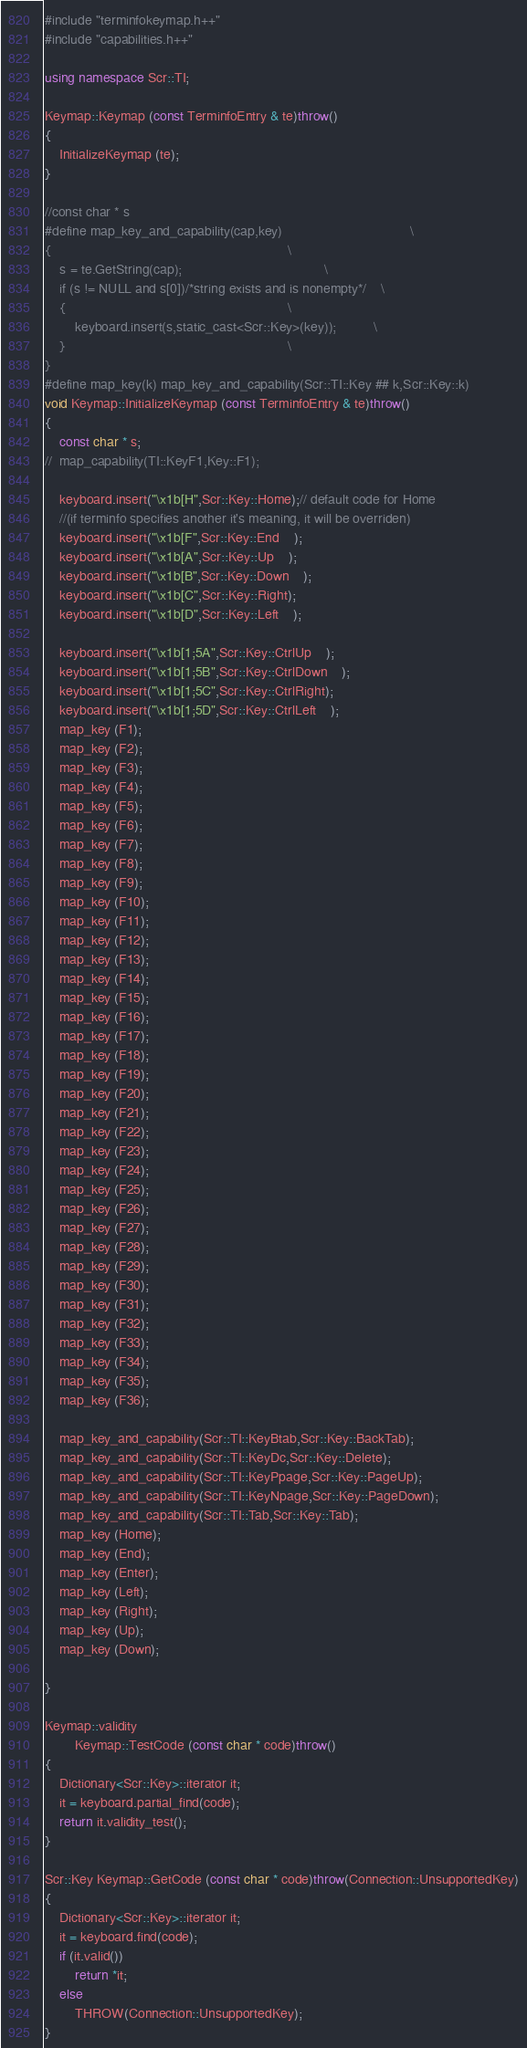<code> <loc_0><loc_0><loc_500><loc_500><_C++_>#include "terminfokeymap.h++"
#include "capabilities.h++"

using namespace Scr::TI;

Keymap::Keymap (const TerminfoEntry & te)throw()
{
	InitializeKeymap (te);
}

//const char * s
#define map_key_and_capability(cap,key)									\
{																\
	s = te.GetString(cap);										\
	if (s != NULL and s[0])/*string exists and is nonempty*/	\
	{															\
		keyboard.insert(s,static_cast<Scr::Key>(key));			\
	}															\
}
#define map_key(k) map_key_and_capability(Scr::TI::Key ## k,Scr::Key::k)
void Keymap::InitializeKeymap (const TerminfoEntry & te)throw()
{
	const char * s;
//	map_capability(TI::KeyF1,Key::F1);
	
	keyboard.insert("\x1b[H",Scr::Key::Home);// default code for Home 
	//(if terminfo specifies another it's meaning, it will be overriden)
	keyboard.insert("\x1b[F",Scr::Key::End	);
 	keyboard.insert("\x1b[A",Scr::Key::Up	);
 	keyboard.insert("\x1b[B",Scr::Key::Down	);
 	keyboard.insert("\x1b[C",Scr::Key::Right);
 	keyboard.insert("\x1b[D",Scr::Key::Left	);
	
 	keyboard.insert("\x1b[1;5A",Scr::Key::CtrlUp	);
 	keyboard.insert("\x1b[1;5B",Scr::Key::CtrlDown	);
 	keyboard.insert("\x1b[1;5C",Scr::Key::CtrlRight);
 	keyboard.insert("\x1b[1;5D",Scr::Key::CtrlLeft	);
	map_key (F1);
	map_key (F2);
	map_key (F3);
	map_key (F4);
	map_key (F5);
	map_key (F6);
	map_key (F7);
	map_key (F8);
	map_key (F9);
	map_key (F10);
	map_key (F11);
	map_key (F12);
	map_key (F13);
	map_key (F14);
	map_key (F15);
	map_key (F16);
	map_key (F17);
	map_key (F18);
	map_key (F19);
	map_key (F20);
	map_key (F21);
	map_key (F22);
	map_key (F23);
	map_key (F24);
	map_key (F25);
	map_key (F26);
	map_key (F27);
	map_key (F28);
	map_key (F29);
	map_key (F30);
	map_key (F31);
	map_key (F32);
	map_key (F33);
	map_key (F34);
	map_key (F35);
	map_key (F36);
	
	map_key_and_capability(Scr::TI::KeyBtab,Scr::Key::BackTab);
	map_key_and_capability(Scr::TI::KeyDc,Scr::Key::Delete);
	map_key_and_capability(Scr::TI::KeyPpage,Scr::Key::PageUp);
	map_key_and_capability(Scr::TI::KeyNpage,Scr::Key::PageDown);
	map_key_and_capability(Scr::TI::Tab,Scr::Key::Tab);
	map_key (Home);
	map_key (End);
	map_key (Enter);
	map_key (Left);
	map_key (Right);
	map_key (Up);
	map_key (Down);
	
}

Keymap::validity
		Keymap::TestCode (const char * code)throw()
{
	Dictionary<Scr::Key>::iterator it;
	it = keyboard.partial_find(code);
	return it.validity_test();
}

Scr::Key Keymap::GetCode (const char * code)throw(Connection::UnsupportedKey)
{
	Dictionary<Scr::Key>::iterator it;
	it = keyboard.find(code);
	if (it.valid())
		return *it;
	else
		THROW(Connection::UnsupportedKey);
}
</code> 